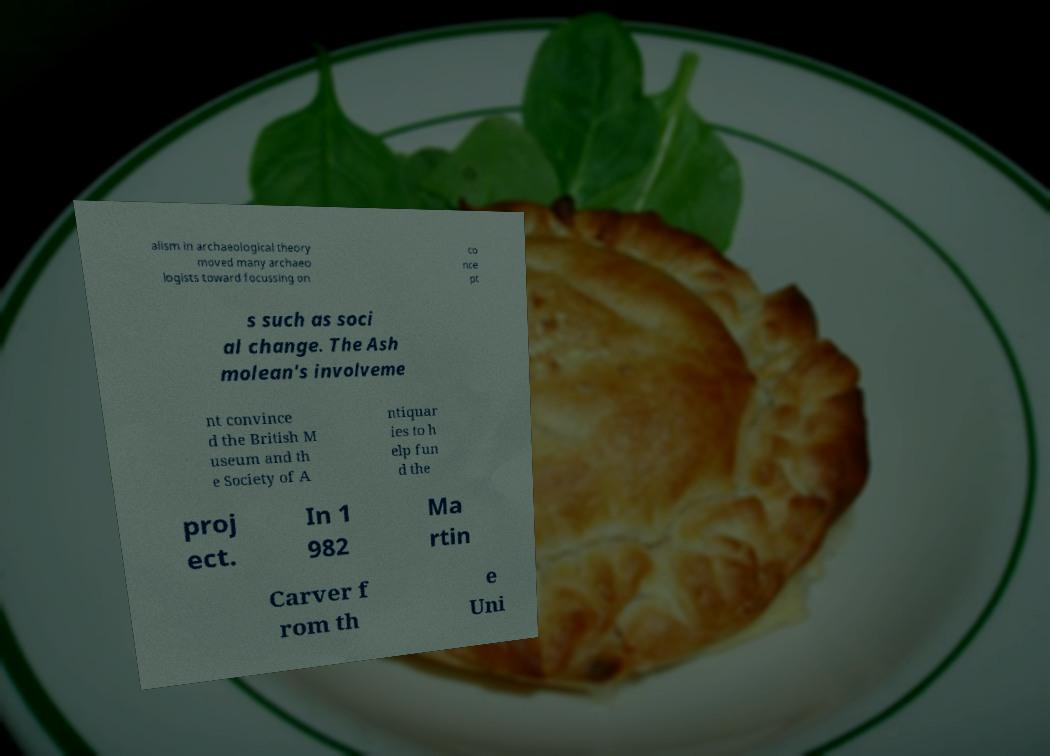There's text embedded in this image that I need extracted. Can you transcribe it verbatim? alism in archaeological theory moved many archaeo logists toward focussing on co nce pt s such as soci al change. The Ash molean's involveme nt convince d the British M useum and th e Society of A ntiquar ies to h elp fun d the proj ect. In 1 982 Ma rtin Carver f rom th e Uni 